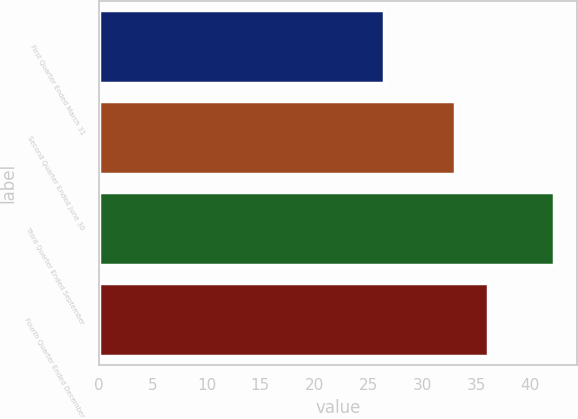Convert chart. <chart><loc_0><loc_0><loc_500><loc_500><bar_chart><fcel>First Quarter Ended March 31<fcel>Second Quarter Ended June 30<fcel>Third Quarter Ended September<fcel>Fourth Quarter Ended December<nl><fcel>26.49<fcel>33.03<fcel>42.27<fcel>36.11<nl></chart> 